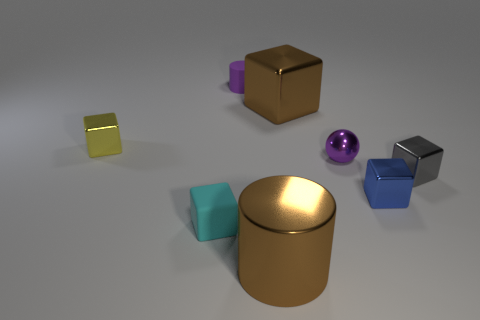How many matte objects are the same color as the large metallic cylinder?
Offer a very short reply. 0. There is a large cube that is the same color as the big cylinder; what is its material?
Give a very brief answer. Metal. What is the small sphere made of?
Your response must be concise. Metal. Do the brown thing behind the tiny cyan thing and the gray object have the same material?
Ensure brevity in your answer.  Yes. There is a large brown thing in front of the gray shiny object; what shape is it?
Keep it short and to the point. Cylinder. There is a cyan object that is the same size as the purple metal thing; what is it made of?
Offer a very short reply. Rubber. How many objects are either metallic objects in front of the small yellow block or tiny purple things behind the tiny purple metal ball?
Ensure brevity in your answer.  5. There is a cylinder that is the same material as the tiny cyan block; what is its size?
Your answer should be very brief. Small. How many metal objects are either tiny blocks or tiny blue spheres?
Keep it short and to the point. 3. The purple ball has what size?
Provide a short and direct response. Small. 